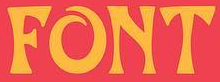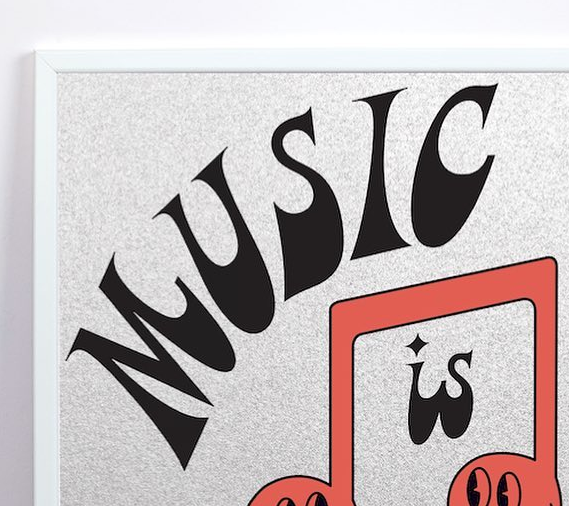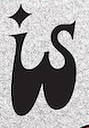Read the text from these images in sequence, separated by a semicolon. FONT; MUSIC; is 